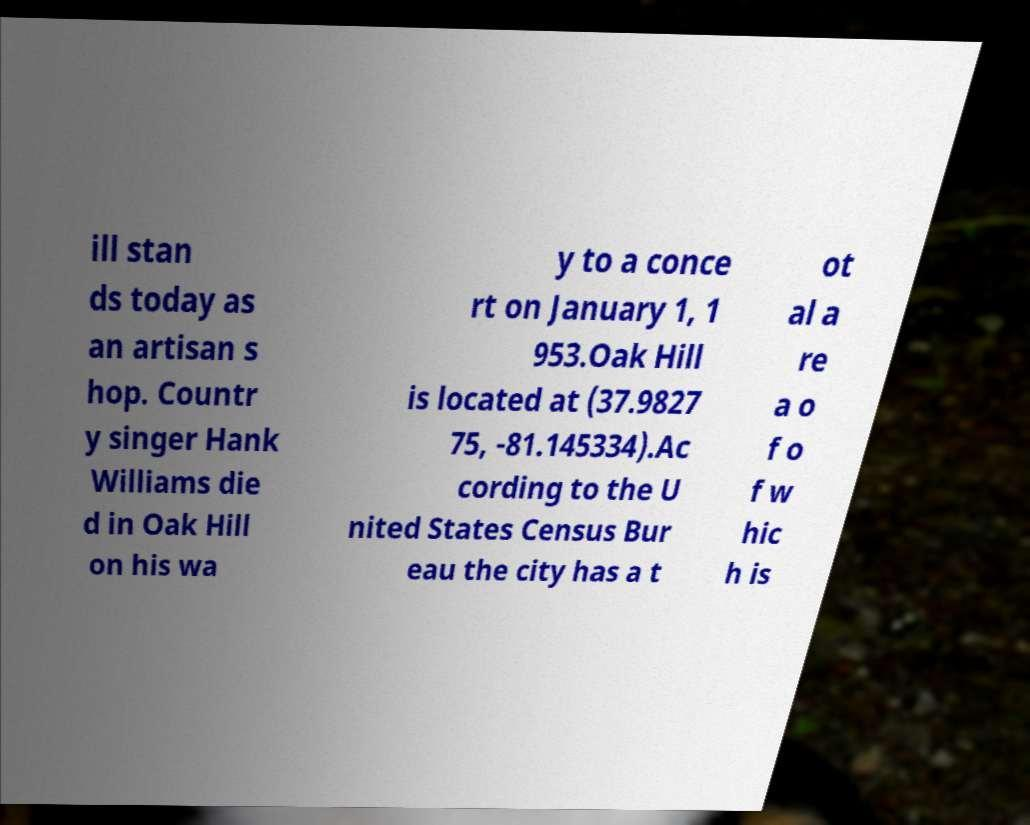Could you assist in decoding the text presented in this image and type it out clearly? ill stan ds today as an artisan s hop. Countr y singer Hank Williams die d in Oak Hill on his wa y to a conce rt on January 1, 1 953.Oak Hill is located at (37.9827 75, -81.145334).Ac cording to the U nited States Census Bur eau the city has a t ot al a re a o f o f w hic h is 